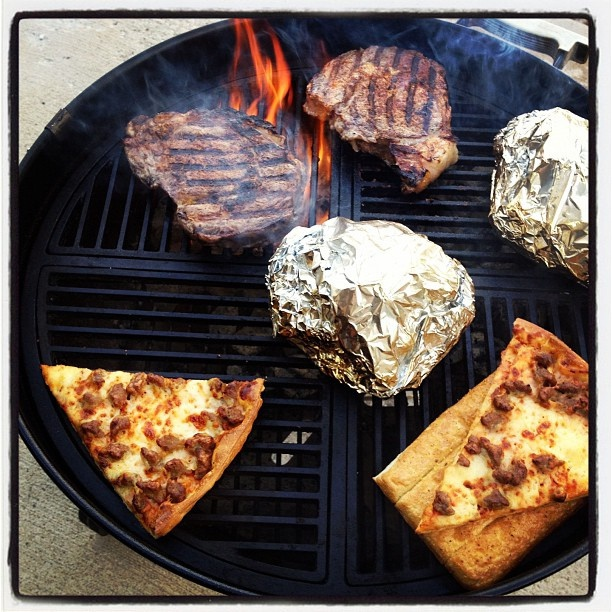Describe the objects in this image and their specific colors. I can see a pizza in white, orange, brown, khaki, and maroon tones in this image. 